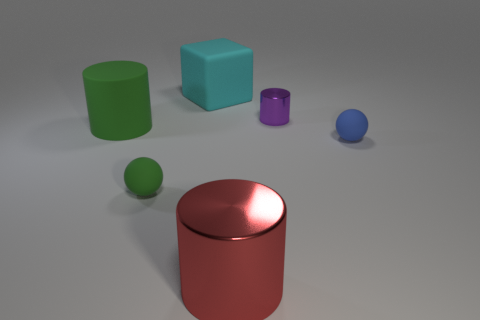Add 1 small matte objects. How many objects exist? 7 Subtract all blocks. How many objects are left? 5 Add 1 large red metal objects. How many large red metal objects are left? 2 Add 4 big red shiny spheres. How many big red shiny spheres exist? 4 Subtract 1 blue spheres. How many objects are left? 5 Subtract all large yellow shiny cylinders. Subtract all green rubber cylinders. How many objects are left? 5 